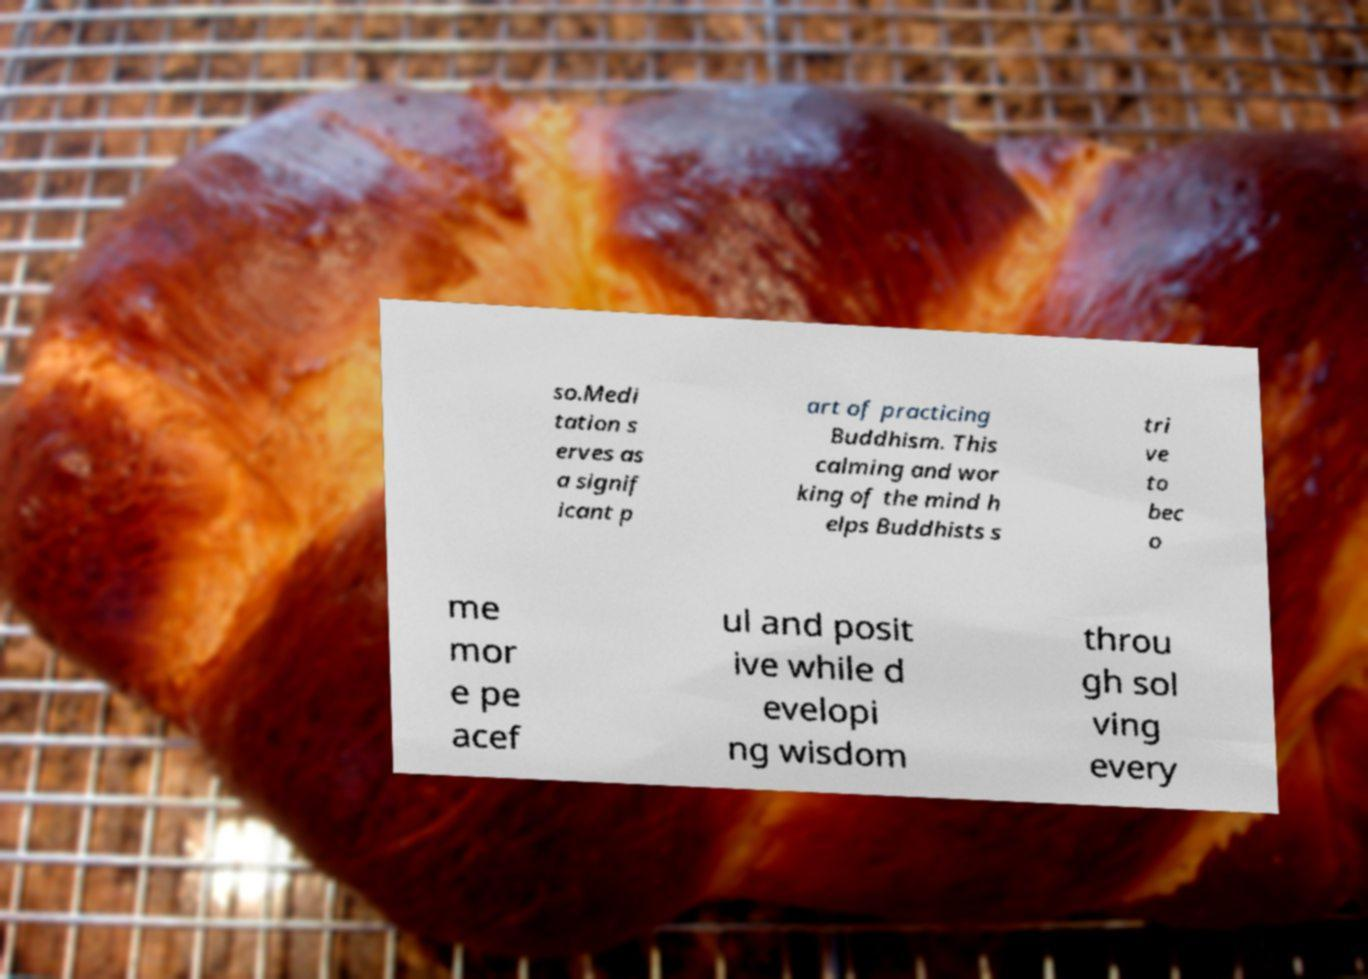I need the written content from this picture converted into text. Can you do that? so.Medi tation s erves as a signif icant p art of practicing Buddhism. This calming and wor king of the mind h elps Buddhists s tri ve to bec o me mor e pe acef ul and posit ive while d evelopi ng wisdom throu gh sol ving every 